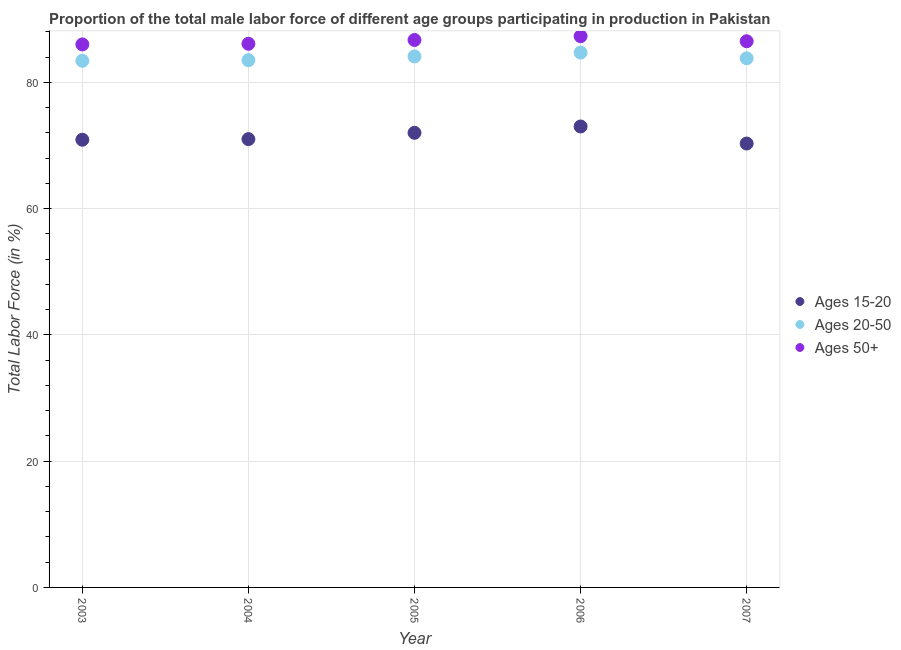Is the number of dotlines equal to the number of legend labels?
Provide a short and direct response. Yes. What is the percentage of male labor force within the age group 15-20 in 2003?
Ensure brevity in your answer.  70.9. Across all years, what is the maximum percentage of male labor force above age 50?
Your answer should be very brief. 87.3. Across all years, what is the minimum percentage of male labor force above age 50?
Provide a succinct answer. 86. In which year was the percentage of male labor force within the age group 20-50 maximum?
Give a very brief answer. 2006. What is the total percentage of male labor force above age 50 in the graph?
Your answer should be very brief. 432.6. What is the difference between the percentage of male labor force within the age group 15-20 in 2006 and that in 2007?
Make the answer very short. 2.7. What is the difference between the percentage of male labor force above age 50 in 2004 and the percentage of male labor force within the age group 15-20 in 2005?
Offer a terse response. 14.1. What is the average percentage of male labor force within the age group 15-20 per year?
Make the answer very short. 71.44. In the year 2003, what is the difference between the percentage of male labor force above age 50 and percentage of male labor force within the age group 15-20?
Give a very brief answer. 15.1. What is the ratio of the percentage of male labor force above age 50 in 2003 to that in 2004?
Provide a short and direct response. 1. Is the percentage of male labor force within the age group 20-50 in 2003 less than that in 2004?
Ensure brevity in your answer.  Yes. Is the difference between the percentage of male labor force above age 50 in 2004 and 2005 greater than the difference between the percentage of male labor force within the age group 20-50 in 2004 and 2005?
Ensure brevity in your answer.  No. What is the difference between the highest and the second highest percentage of male labor force within the age group 15-20?
Make the answer very short. 1. What is the difference between the highest and the lowest percentage of male labor force within the age group 15-20?
Give a very brief answer. 2.7. Is the sum of the percentage of male labor force within the age group 15-20 in 2003 and 2006 greater than the maximum percentage of male labor force above age 50 across all years?
Offer a very short reply. Yes. Is the percentage of male labor force above age 50 strictly greater than the percentage of male labor force within the age group 20-50 over the years?
Provide a succinct answer. Yes. How many dotlines are there?
Provide a succinct answer. 3. What is the difference between two consecutive major ticks on the Y-axis?
Provide a succinct answer. 20. Does the graph contain grids?
Your answer should be very brief. Yes. How are the legend labels stacked?
Make the answer very short. Vertical. What is the title of the graph?
Offer a very short reply. Proportion of the total male labor force of different age groups participating in production in Pakistan. What is the label or title of the X-axis?
Ensure brevity in your answer.  Year. What is the label or title of the Y-axis?
Give a very brief answer. Total Labor Force (in %). What is the Total Labor Force (in %) of Ages 15-20 in 2003?
Ensure brevity in your answer.  70.9. What is the Total Labor Force (in %) of Ages 20-50 in 2003?
Your answer should be very brief. 83.4. What is the Total Labor Force (in %) in Ages 50+ in 2003?
Provide a short and direct response. 86. What is the Total Labor Force (in %) of Ages 15-20 in 2004?
Your answer should be compact. 71. What is the Total Labor Force (in %) in Ages 20-50 in 2004?
Provide a succinct answer. 83.5. What is the Total Labor Force (in %) in Ages 50+ in 2004?
Offer a terse response. 86.1. What is the Total Labor Force (in %) in Ages 15-20 in 2005?
Provide a short and direct response. 72. What is the Total Labor Force (in %) of Ages 20-50 in 2005?
Ensure brevity in your answer.  84.1. What is the Total Labor Force (in %) of Ages 50+ in 2005?
Make the answer very short. 86.7. What is the Total Labor Force (in %) in Ages 20-50 in 2006?
Offer a very short reply. 84.7. What is the Total Labor Force (in %) of Ages 50+ in 2006?
Provide a succinct answer. 87.3. What is the Total Labor Force (in %) of Ages 15-20 in 2007?
Ensure brevity in your answer.  70.3. What is the Total Labor Force (in %) of Ages 20-50 in 2007?
Offer a terse response. 83.8. What is the Total Labor Force (in %) of Ages 50+ in 2007?
Ensure brevity in your answer.  86.5. Across all years, what is the maximum Total Labor Force (in %) in Ages 15-20?
Give a very brief answer. 73. Across all years, what is the maximum Total Labor Force (in %) of Ages 20-50?
Offer a terse response. 84.7. Across all years, what is the maximum Total Labor Force (in %) of Ages 50+?
Your answer should be compact. 87.3. Across all years, what is the minimum Total Labor Force (in %) in Ages 15-20?
Offer a terse response. 70.3. Across all years, what is the minimum Total Labor Force (in %) in Ages 20-50?
Your answer should be very brief. 83.4. What is the total Total Labor Force (in %) of Ages 15-20 in the graph?
Keep it short and to the point. 357.2. What is the total Total Labor Force (in %) in Ages 20-50 in the graph?
Make the answer very short. 419.5. What is the total Total Labor Force (in %) in Ages 50+ in the graph?
Ensure brevity in your answer.  432.6. What is the difference between the Total Labor Force (in %) in Ages 15-20 in 2003 and that in 2004?
Give a very brief answer. -0.1. What is the difference between the Total Labor Force (in %) of Ages 50+ in 2003 and that in 2004?
Keep it short and to the point. -0.1. What is the difference between the Total Labor Force (in %) of Ages 15-20 in 2003 and that in 2005?
Your answer should be very brief. -1.1. What is the difference between the Total Labor Force (in %) of Ages 20-50 in 2003 and that in 2005?
Your answer should be very brief. -0.7. What is the difference between the Total Labor Force (in %) in Ages 50+ in 2003 and that in 2005?
Offer a terse response. -0.7. What is the difference between the Total Labor Force (in %) of Ages 15-20 in 2003 and that in 2006?
Your response must be concise. -2.1. What is the difference between the Total Labor Force (in %) of Ages 20-50 in 2003 and that in 2006?
Offer a terse response. -1.3. What is the difference between the Total Labor Force (in %) of Ages 50+ in 2003 and that in 2006?
Your response must be concise. -1.3. What is the difference between the Total Labor Force (in %) of Ages 15-20 in 2003 and that in 2007?
Provide a succinct answer. 0.6. What is the difference between the Total Labor Force (in %) in Ages 15-20 in 2004 and that in 2005?
Offer a terse response. -1. What is the difference between the Total Labor Force (in %) in Ages 15-20 in 2004 and that in 2006?
Your response must be concise. -2. What is the difference between the Total Labor Force (in %) of Ages 20-50 in 2004 and that in 2006?
Offer a terse response. -1.2. What is the difference between the Total Labor Force (in %) in Ages 50+ in 2004 and that in 2006?
Give a very brief answer. -1.2. What is the difference between the Total Labor Force (in %) in Ages 15-20 in 2004 and that in 2007?
Your response must be concise. 0.7. What is the difference between the Total Labor Force (in %) of Ages 15-20 in 2005 and that in 2006?
Keep it short and to the point. -1. What is the difference between the Total Labor Force (in %) in Ages 20-50 in 2005 and that in 2006?
Your answer should be compact. -0.6. What is the difference between the Total Labor Force (in %) of Ages 50+ in 2005 and that in 2006?
Your answer should be very brief. -0.6. What is the difference between the Total Labor Force (in %) of Ages 50+ in 2005 and that in 2007?
Your response must be concise. 0.2. What is the difference between the Total Labor Force (in %) in Ages 15-20 in 2006 and that in 2007?
Ensure brevity in your answer.  2.7. What is the difference between the Total Labor Force (in %) of Ages 15-20 in 2003 and the Total Labor Force (in %) of Ages 20-50 in 2004?
Keep it short and to the point. -12.6. What is the difference between the Total Labor Force (in %) in Ages 15-20 in 2003 and the Total Labor Force (in %) in Ages 50+ in 2004?
Keep it short and to the point. -15.2. What is the difference between the Total Labor Force (in %) in Ages 20-50 in 2003 and the Total Labor Force (in %) in Ages 50+ in 2004?
Provide a short and direct response. -2.7. What is the difference between the Total Labor Force (in %) in Ages 15-20 in 2003 and the Total Labor Force (in %) in Ages 50+ in 2005?
Make the answer very short. -15.8. What is the difference between the Total Labor Force (in %) of Ages 15-20 in 2003 and the Total Labor Force (in %) of Ages 20-50 in 2006?
Make the answer very short. -13.8. What is the difference between the Total Labor Force (in %) of Ages 15-20 in 2003 and the Total Labor Force (in %) of Ages 50+ in 2006?
Make the answer very short. -16.4. What is the difference between the Total Labor Force (in %) in Ages 15-20 in 2003 and the Total Labor Force (in %) in Ages 20-50 in 2007?
Your answer should be compact. -12.9. What is the difference between the Total Labor Force (in %) in Ages 15-20 in 2003 and the Total Labor Force (in %) in Ages 50+ in 2007?
Keep it short and to the point. -15.6. What is the difference between the Total Labor Force (in %) of Ages 15-20 in 2004 and the Total Labor Force (in %) of Ages 20-50 in 2005?
Ensure brevity in your answer.  -13.1. What is the difference between the Total Labor Force (in %) of Ages 15-20 in 2004 and the Total Labor Force (in %) of Ages 50+ in 2005?
Offer a terse response. -15.7. What is the difference between the Total Labor Force (in %) of Ages 15-20 in 2004 and the Total Labor Force (in %) of Ages 20-50 in 2006?
Make the answer very short. -13.7. What is the difference between the Total Labor Force (in %) of Ages 15-20 in 2004 and the Total Labor Force (in %) of Ages 50+ in 2006?
Provide a succinct answer. -16.3. What is the difference between the Total Labor Force (in %) of Ages 20-50 in 2004 and the Total Labor Force (in %) of Ages 50+ in 2006?
Your response must be concise. -3.8. What is the difference between the Total Labor Force (in %) of Ages 15-20 in 2004 and the Total Labor Force (in %) of Ages 20-50 in 2007?
Your response must be concise. -12.8. What is the difference between the Total Labor Force (in %) in Ages 15-20 in 2004 and the Total Labor Force (in %) in Ages 50+ in 2007?
Provide a succinct answer. -15.5. What is the difference between the Total Labor Force (in %) in Ages 15-20 in 2005 and the Total Labor Force (in %) in Ages 20-50 in 2006?
Offer a terse response. -12.7. What is the difference between the Total Labor Force (in %) in Ages 15-20 in 2005 and the Total Labor Force (in %) in Ages 50+ in 2006?
Provide a short and direct response. -15.3. What is the difference between the Total Labor Force (in %) in Ages 20-50 in 2005 and the Total Labor Force (in %) in Ages 50+ in 2006?
Make the answer very short. -3.2. What is the difference between the Total Labor Force (in %) of Ages 15-20 in 2005 and the Total Labor Force (in %) of Ages 20-50 in 2007?
Your answer should be compact. -11.8. What is the average Total Labor Force (in %) in Ages 15-20 per year?
Offer a very short reply. 71.44. What is the average Total Labor Force (in %) of Ages 20-50 per year?
Your answer should be compact. 83.9. What is the average Total Labor Force (in %) in Ages 50+ per year?
Offer a very short reply. 86.52. In the year 2003, what is the difference between the Total Labor Force (in %) of Ages 15-20 and Total Labor Force (in %) of Ages 20-50?
Offer a very short reply. -12.5. In the year 2003, what is the difference between the Total Labor Force (in %) in Ages 15-20 and Total Labor Force (in %) in Ages 50+?
Provide a short and direct response. -15.1. In the year 2003, what is the difference between the Total Labor Force (in %) of Ages 20-50 and Total Labor Force (in %) of Ages 50+?
Ensure brevity in your answer.  -2.6. In the year 2004, what is the difference between the Total Labor Force (in %) of Ages 15-20 and Total Labor Force (in %) of Ages 50+?
Your answer should be very brief. -15.1. In the year 2005, what is the difference between the Total Labor Force (in %) in Ages 15-20 and Total Labor Force (in %) in Ages 50+?
Make the answer very short. -14.7. In the year 2006, what is the difference between the Total Labor Force (in %) in Ages 15-20 and Total Labor Force (in %) in Ages 20-50?
Make the answer very short. -11.7. In the year 2006, what is the difference between the Total Labor Force (in %) in Ages 15-20 and Total Labor Force (in %) in Ages 50+?
Offer a very short reply. -14.3. In the year 2007, what is the difference between the Total Labor Force (in %) in Ages 15-20 and Total Labor Force (in %) in Ages 20-50?
Offer a very short reply. -13.5. In the year 2007, what is the difference between the Total Labor Force (in %) in Ages 15-20 and Total Labor Force (in %) in Ages 50+?
Offer a very short reply. -16.2. What is the ratio of the Total Labor Force (in %) of Ages 15-20 in 2003 to that in 2004?
Provide a succinct answer. 1. What is the ratio of the Total Labor Force (in %) in Ages 15-20 in 2003 to that in 2005?
Offer a very short reply. 0.98. What is the ratio of the Total Labor Force (in %) in Ages 50+ in 2003 to that in 2005?
Your answer should be compact. 0.99. What is the ratio of the Total Labor Force (in %) of Ages 15-20 in 2003 to that in 2006?
Offer a terse response. 0.97. What is the ratio of the Total Labor Force (in %) of Ages 20-50 in 2003 to that in 2006?
Provide a short and direct response. 0.98. What is the ratio of the Total Labor Force (in %) in Ages 50+ in 2003 to that in 2006?
Make the answer very short. 0.99. What is the ratio of the Total Labor Force (in %) of Ages 15-20 in 2003 to that in 2007?
Your answer should be compact. 1.01. What is the ratio of the Total Labor Force (in %) of Ages 50+ in 2003 to that in 2007?
Give a very brief answer. 0.99. What is the ratio of the Total Labor Force (in %) in Ages 15-20 in 2004 to that in 2005?
Your answer should be very brief. 0.99. What is the ratio of the Total Labor Force (in %) in Ages 20-50 in 2004 to that in 2005?
Give a very brief answer. 0.99. What is the ratio of the Total Labor Force (in %) of Ages 50+ in 2004 to that in 2005?
Your answer should be very brief. 0.99. What is the ratio of the Total Labor Force (in %) in Ages 15-20 in 2004 to that in 2006?
Keep it short and to the point. 0.97. What is the ratio of the Total Labor Force (in %) of Ages 20-50 in 2004 to that in 2006?
Keep it short and to the point. 0.99. What is the ratio of the Total Labor Force (in %) in Ages 50+ in 2004 to that in 2006?
Keep it short and to the point. 0.99. What is the ratio of the Total Labor Force (in %) of Ages 20-50 in 2004 to that in 2007?
Give a very brief answer. 1. What is the ratio of the Total Labor Force (in %) in Ages 15-20 in 2005 to that in 2006?
Provide a succinct answer. 0.99. What is the ratio of the Total Labor Force (in %) of Ages 50+ in 2005 to that in 2006?
Your response must be concise. 0.99. What is the ratio of the Total Labor Force (in %) of Ages 15-20 in 2005 to that in 2007?
Keep it short and to the point. 1.02. What is the ratio of the Total Labor Force (in %) of Ages 20-50 in 2005 to that in 2007?
Make the answer very short. 1. What is the ratio of the Total Labor Force (in %) of Ages 50+ in 2005 to that in 2007?
Make the answer very short. 1. What is the ratio of the Total Labor Force (in %) of Ages 15-20 in 2006 to that in 2007?
Give a very brief answer. 1.04. What is the ratio of the Total Labor Force (in %) of Ages 20-50 in 2006 to that in 2007?
Give a very brief answer. 1.01. What is the ratio of the Total Labor Force (in %) in Ages 50+ in 2006 to that in 2007?
Give a very brief answer. 1.01. What is the difference between the highest and the second highest Total Labor Force (in %) in Ages 50+?
Keep it short and to the point. 0.6. What is the difference between the highest and the lowest Total Labor Force (in %) in Ages 20-50?
Your response must be concise. 1.3. What is the difference between the highest and the lowest Total Labor Force (in %) in Ages 50+?
Your answer should be very brief. 1.3. 